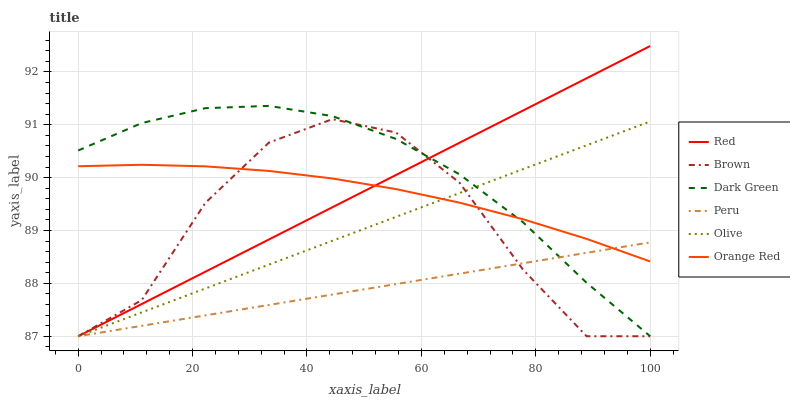Does Peru have the minimum area under the curve?
Answer yes or no. Yes. Does Dark Green have the maximum area under the curve?
Answer yes or no. Yes. Does Olive have the minimum area under the curve?
Answer yes or no. No. Does Olive have the maximum area under the curve?
Answer yes or no. No. Is Peru the smoothest?
Answer yes or no. Yes. Is Brown the roughest?
Answer yes or no. Yes. Is Olive the smoothest?
Answer yes or no. No. Is Olive the roughest?
Answer yes or no. No. Does Brown have the lowest value?
Answer yes or no. Yes. Does Orange Red have the lowest value?
Answer yes or no. No. Does Red have the highest value?
Answer yes or no. Yes. Does Olive have the highest value?
Answer yes or no. No. Does Dark Green intersect Brown?
Answer yes or no. Yes. Is Dark Green less than Brown?
Answer yes or no. No. Is Dark Green greater than Brown?
Answer yes or no. No. 